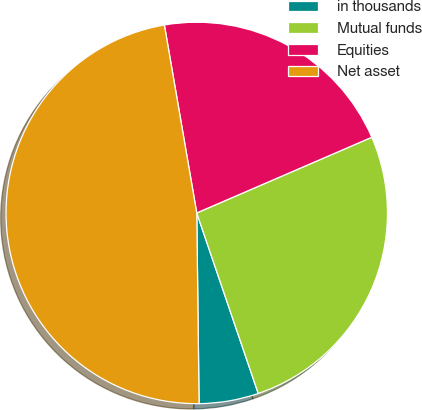<chart> <loc_0><loc_0><loc_500><loc_500><pie_chart><fcel>in thousands<fcel>Mutual funds<fcel>Equities<fcel>Net asset<nl><fcel>5.03%<fcel>26.27%<fcel>21.22%<fcel>47.48%<nl></chart> 